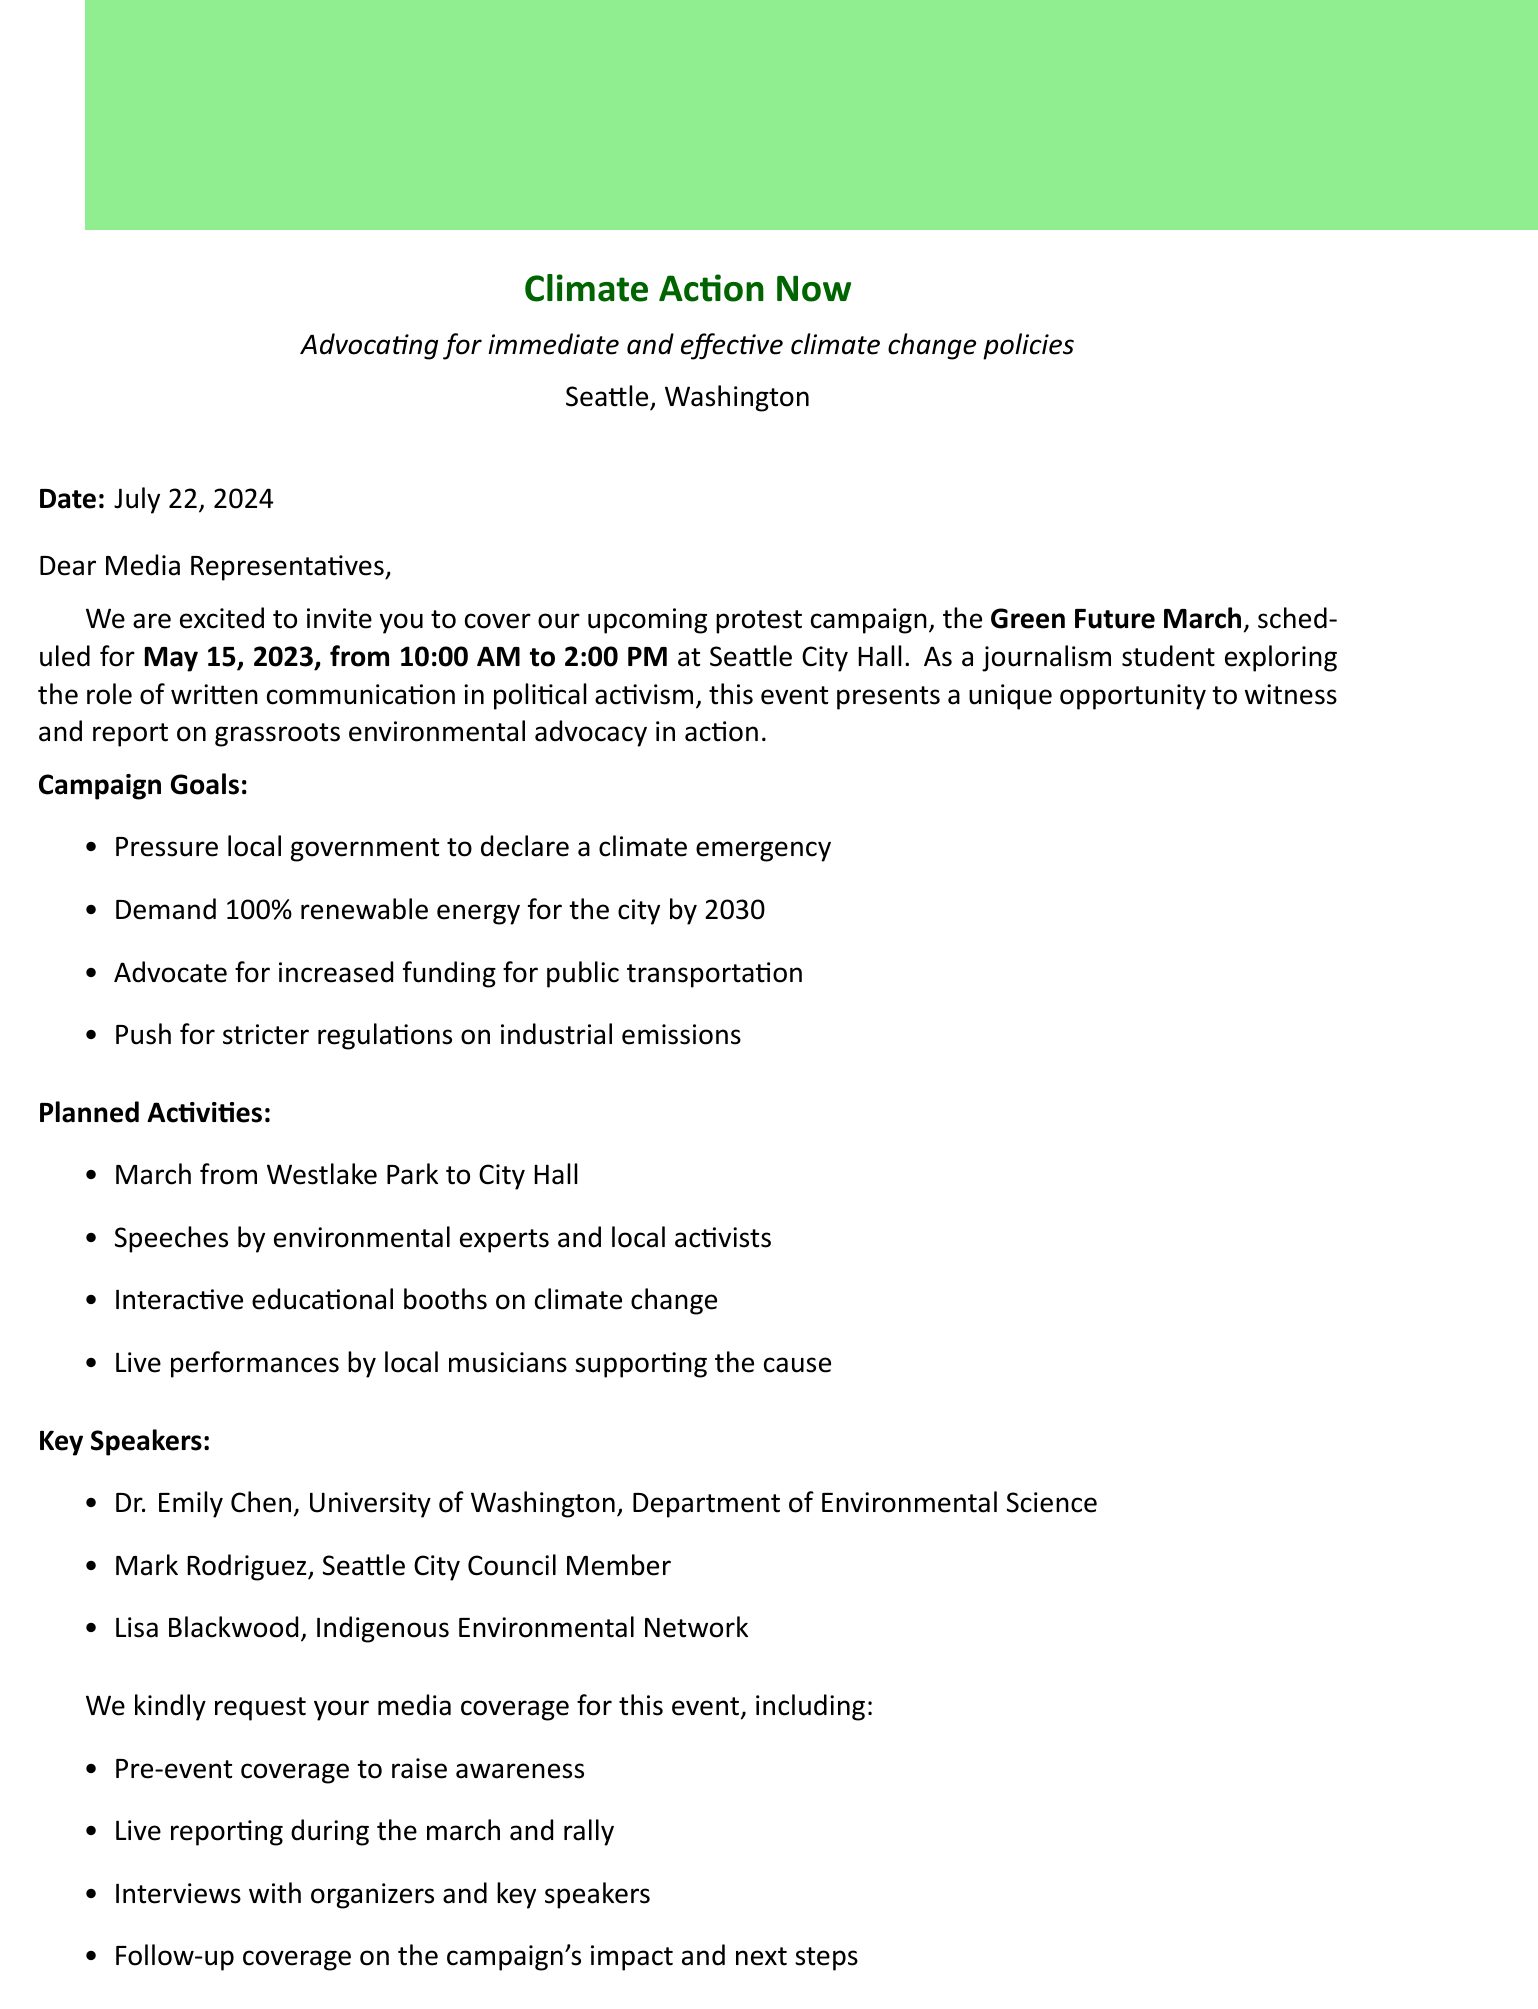what is the name of the organization? The organization is identified in the document as Climate Action Now.
Answer: Climate Action Now who is the contact person for media inquiries? The letter specifies the contact person's name and position as Sarah Thompson, the Communications Director.
Answer: Sarah Thompson when is the Green Future March scheduled to take place? The document states the protest campaign's date is May 15, 2023.
Answer: May 15, 2023 how many expected participants are there for the event? The letter mentions that the expected number of participants for the campaign is 5000.
Answer: 5000 what is one of the campaign goals? The document lists various campaign goals, one of which includes demanding 100% renewable energy for the city by 2030.
Answer: Demand 100% renewable energy for the city by 2030 who is one of the key speakers mentioned in the letter? The document lists several key speakers, one of whom is Dr. Emily Chen.
Answer: Dr. Emily Chen what is requested from the media? The letter outlines specific requests from media representatives, including live reporting during the march and rally.
Answer: Live reporting during the march and rally what social media platform is the organization using? The document mentions several platforms, including Twitter and Facebook, for live updates.
Answer: Twitter what opportunity does the event present for journalism students? The document emphasizes that the event is a valuable opportunity for journalism students to practice live reporting and analyze grassroots campaigns.
Answer: Practice live reporting and analyze grassroots campaigns 